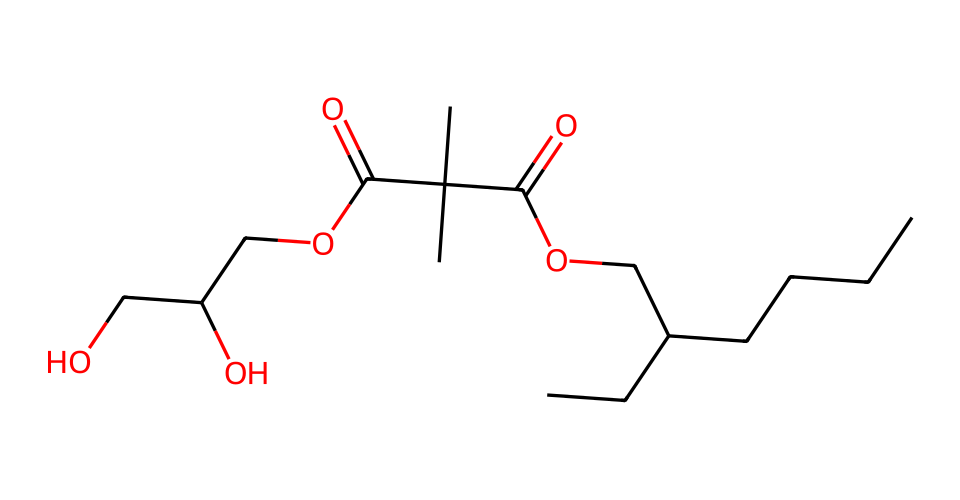How many carbon atoms are present in this molecule? By examining the SMILES representation, we can identify the segments "CCCCC" and "C(C)(C)" as well as the carbon atoms in the "C(=O)" groups. Counting each occurrence yields a total of 12 carbon atoms in the structure.
Answer: 12 What type of functional group is indicated by the "C(=O)" part of the SMILES? The "C(=O)" notation represents a carbonyl group, which is characteristic of ketones and aldehydes. In this case, since the carbonyl groups are connected to alkoxy or other substituents, they indicate the presence of ester groups.
Answer: ester How many hydroxyl (–OH) groups are present in the molecule? Observing the structure reveals that the "C(O)" notation indicates hydroxyl groups. By reviewing the SMILES, we can identify two distinct instances of hydroxyl substituents, which means there are two hydroxyl groups in this molecule.
Answer: 2 What does the presence of long hydrocarbon chains suggest about the detergent's properties? The long hydrocarbon chains (evident from the "CCCCC(CC)" part) suggest that the detergent has surfactant properties, which aid in reducing surface tension and improving cleaning ability in aqueous solutions.
Answer: surfactant What is the significance of the eco-friendly aspect of this detergent? Eco-friendly detergents often incorporate biodegradable components and avoid harsh chemicals, as evident in the structure where natural ingredients are represented. This suggests the product is less harmful to the environment compared to conventional detergents.
Answer: biodegradable 